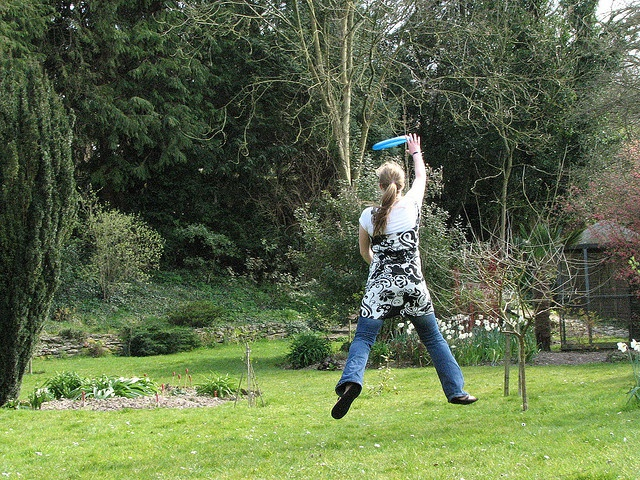Describe the objects in this image and their specific colors. I can see people in darkgreen, white, black, gray, and darkgray tones and frisbee in darkgreen, lightblue, and white tones in this image. 